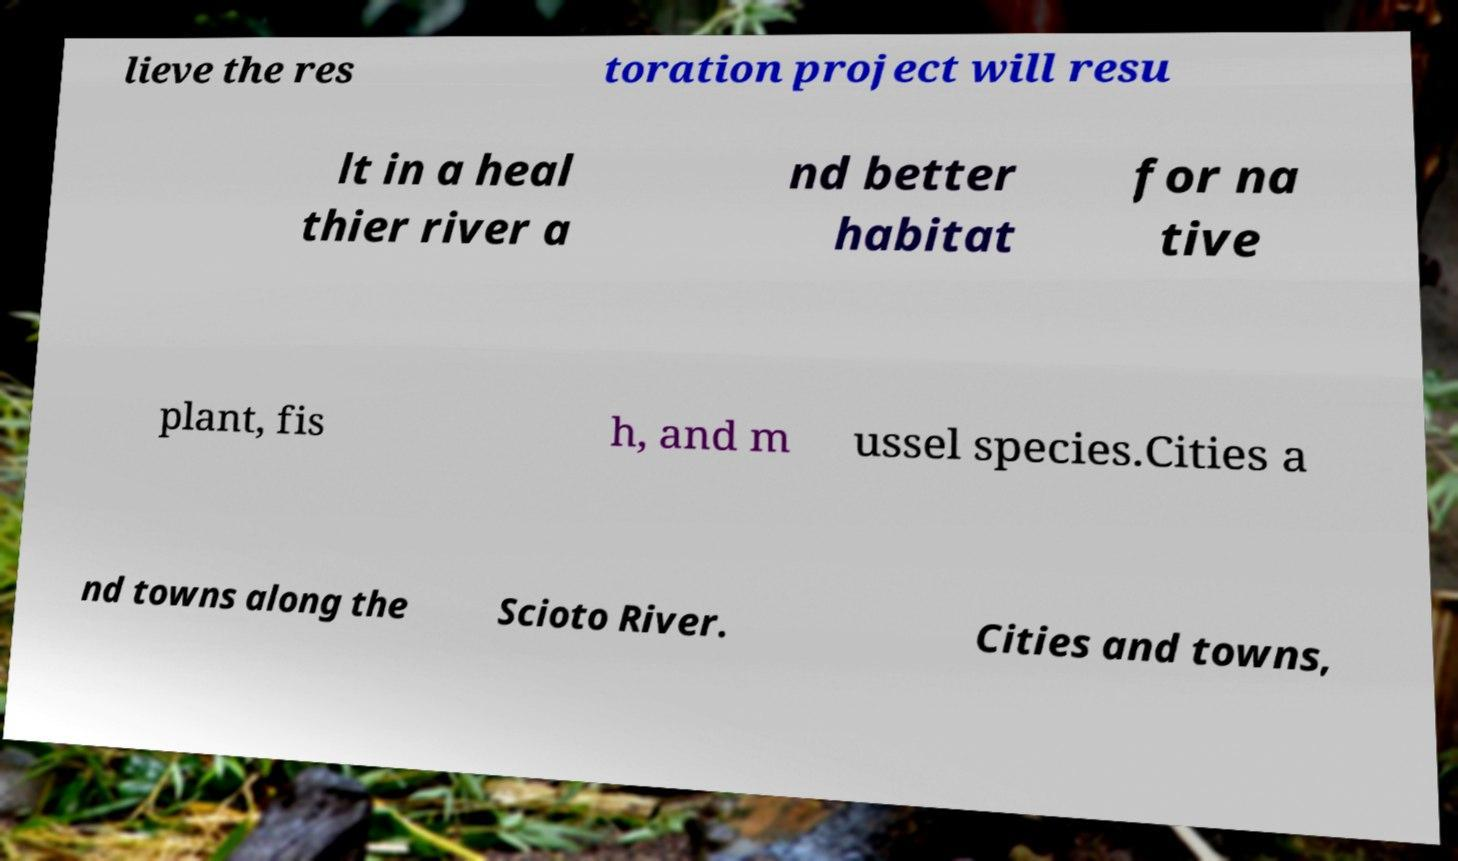Could you assist in decoding the text presented in this image and type it out clearly? lieve the res toration project will resu lt in a heal thier river a nd better habitat for na tive plant, fis h, and m ussel species.Cities a nd towns along the Scioto River. Cities and towns, 